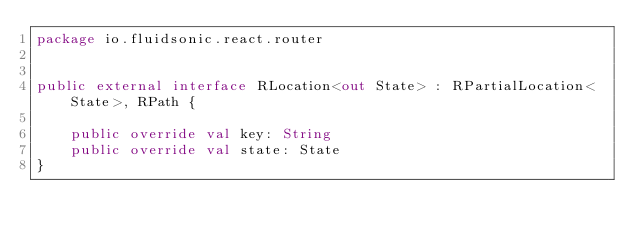Convert code to text. <code><loc_0><loc_0><loc_500><loc_500><_Kotlin_>package io.fluidsonic.react.router


public external interface RLocation<out State> : RPartialLocation<State>, RPath {

	public override val key: String
	public override val state: State
}
</code> 